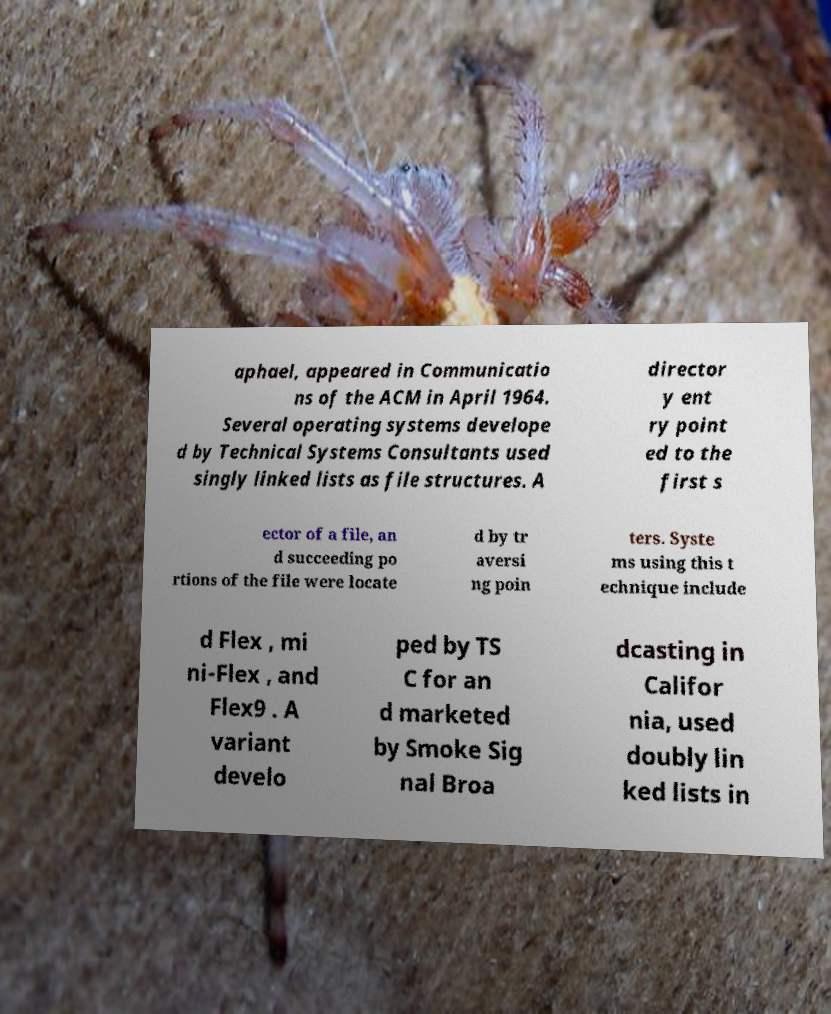Could you extract and type out the text from this image? aphael, appeared in Communicatio ns of the ACM in April 1964. Several operating systems develope d by Technical Systems Consultants used singly linked lists as file structures. A director y ent ry point ed to the first s ector of a file, an d succeeding po rtions of the file were locate d by tr aversi ng poin ters. Syste ms using this t echnique include d Flex , mi ni-Flex , and Flex9 . A variant develo ped by TS C for an d marketed by Smoke Sig nal Broa dcasting in Califor nia, used doubly lin ked lists in 